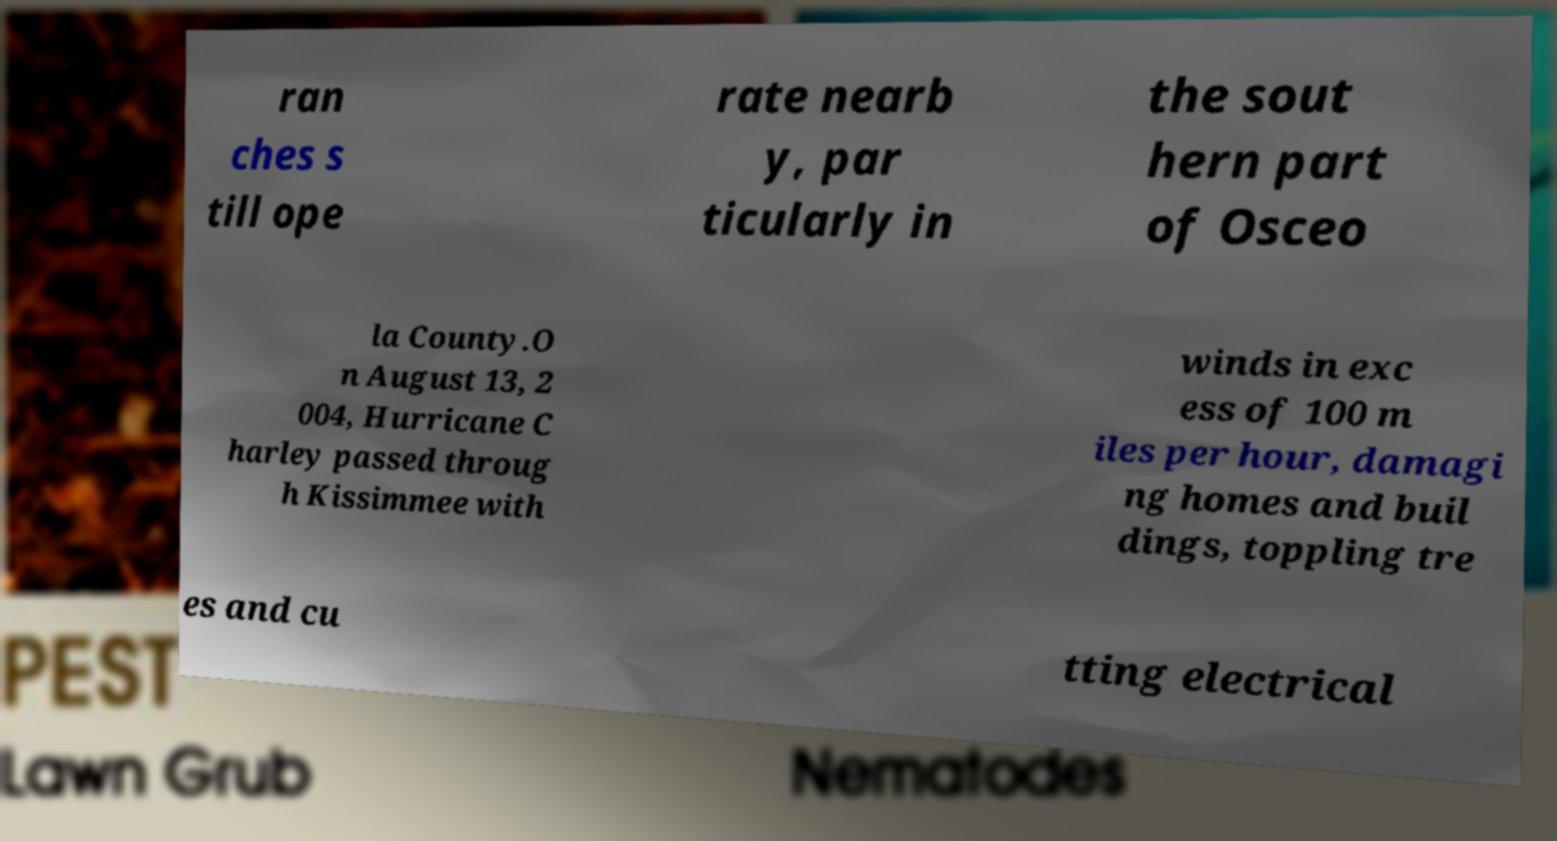What messages or text are displayed in this image? I need them in a readable, typed format. ran ches s till ope rate nearb y, par ticularly in the sout hern part of Osceo la County.O n August 13, 2 004, Hurricane C harley passed throug h Kissimmee with winds in exc ess of 100 m iles per hour, damagi ng homes and buil dings, toppling tre es and cu tting electrical 